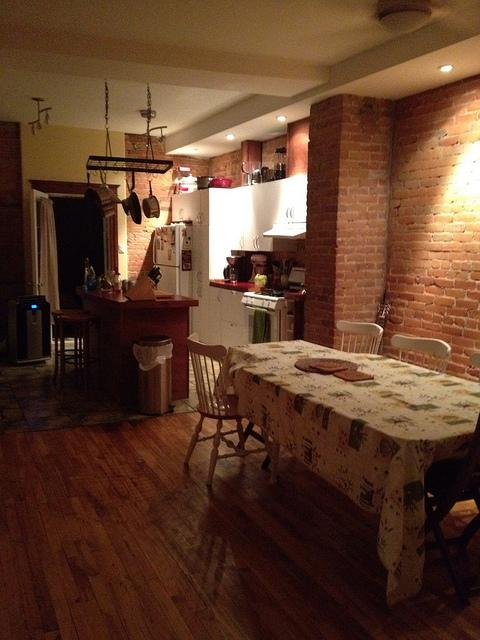What is next to the chair? Please explain your reasoning. tablecloth. The cloth is draped over and down the table. 